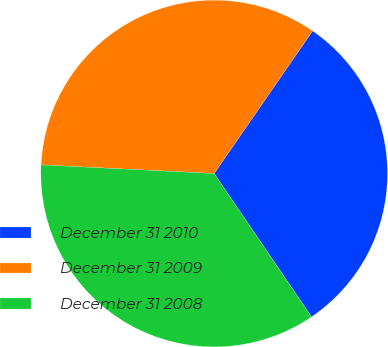Convert chart to OTSL. <chart><loc_0><loc_0><loc_500><loc_500><pie_chart><fcel>December 31 2010<fcel>December 31 2009<fcel>December 31 2008<nl><fcel>30.89%<fcel>33.82%<fcel>35.29%<nl></chart> 